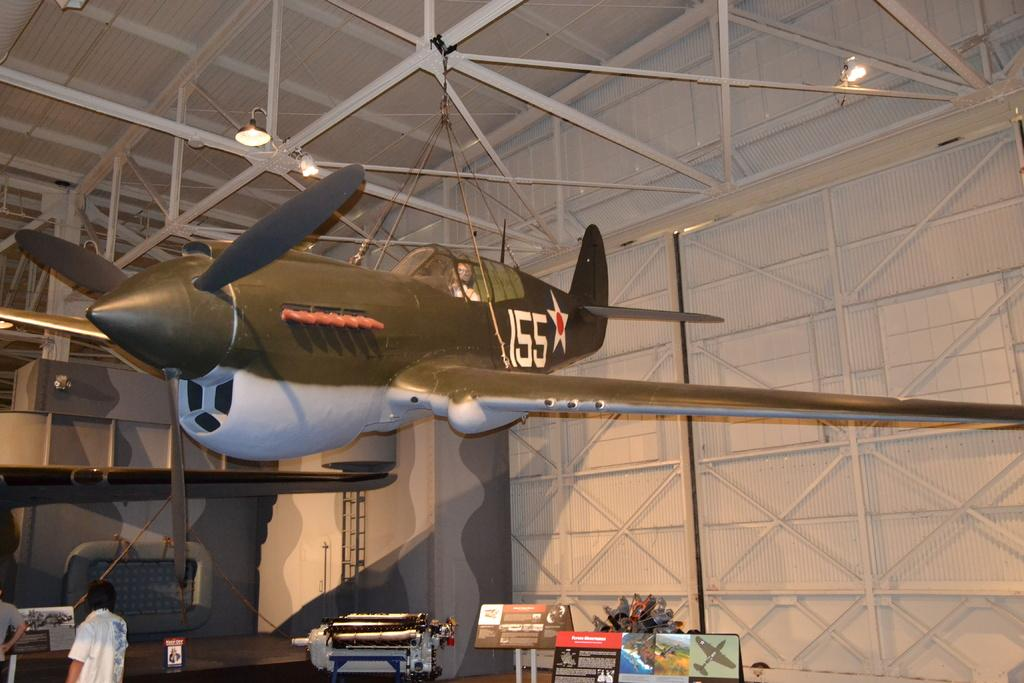<image>
Offer a succinct explanation of the picture presented. a plane hanging in a hangar with the number 155 on it 